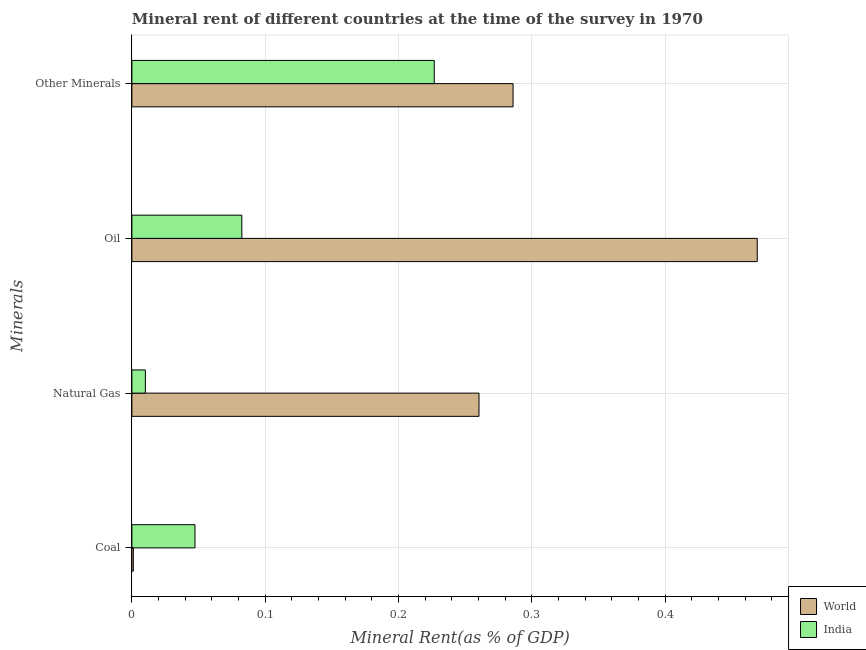How many different coloured bars are there?
Ensure brevity in your answer.  2. How many bars are there on the 4th tick from the top?
Offer a terse response. 2. How many bars are there on the 2nd tick from the bottom?
Ensure brevity in your answer.  2. What is the label of the 4th group of bars from the top?
Provide a succinct answer. Coal. What is the coal rent in India?
Ensure brevity in your answer.  0.05. Across all countries, what is the maximum oil rent?
Provide a succinct answer. 0.47. Across all countries, what is the minimum coal rent?
Your response must be concise. 0. In which country was the coal rent minimum?
Ensure brevity in your answer.  World. What is the total  rent of other minerals in the graph?
Keep it short and to the point. 0.51. What is the difference between the coal rent in World and that in India?
Your answer should be very brief. -0.05. What is the difference between the natural gas rent in World and the oil rent in India?
Give a very brief answer. 0.18. What is the average coal rent per country?
Provide a succinct answer. 0.02. What is the difference between the  rent of other minerals and oil rent in World?
Make the answer very short. -0.18. In how many countries, is the  rent of other minerals greater than 0.26 %?
Offer a terse response. 1. What is the ratio of the oil rent in India to that in World?
Ensure brevity in your answer.  0.18. Is the difference between the coal rent in India and World greater than the difference between the oil rent in India and World?
Give a very brief answer. Yes. What is the difference between the highest and the second highest natural gas rent?
Your answer should be very brief. 0.25. What is the difference between the highest and the lowest  rent of other minerals?
Provide a succinct answer. 0.06. Is the sum of the  rent of other minerals in World and India greater than the maximum oil rent across all countries?
Provide a succinct answer. Yes. Is it the case that in every country, the sum of the  rent of other minerals and natural gas rent is greater than the sum of oil rent and coal rent?
Keep it short and to the point. No. What does the 1st bar from the top in Natural Gas represents?
Offer a very short reply. India. What does the 1st bar from the bottom in Other Minerals represents?
Keep it short and to the point. World. Is it the case that in every country, the sum of the coal rent and natural gas rent is greater than the oil rent?
Ensure brevity in your answer.  No. How many countries are there in the graph?
Make the answer very short. 2. Are the values on the major ticks of X-axis written in scientific E-notation?
Provide a succinct answer. No. Does the graph contain any zero values?
Offer a terse response. No. Does the graph contain grids?
Your response must be concise. Yes. How many legend labels are there?
Make the answer very short. 2. What is the title of the graph?
Make the answer very short. Mineral rent of different countries at the time of the survey in 1970. Does "Kenya" appear as one of the legend labels in the graph?
Your answer should be compact. No. What is the label or title of the X-axis?
Offer a very short reply. Mineral Rent(as % of GDP). What is the label or title of the Y-axis?
Your answer should be compact. Minerals. What is the Mineral Rent(as % of GDP) in World in Coal?
Your response must be concise. 0. What is the Mineral Rent(as % of GDP) of India in Coal?
Offer a terse response. 0.05. What is the Mineral Rent(as % of GDP) in World in Natural Gas?
Offer a terse response. 0.26. What is the Mineral Rent(as % of GDP) in India in Natural Gas?
Offer a terse response. 0.01. What is the Mineral Rent(as % of GDP) of World in Oil?
Provide a succinct answer. 0.47. What is the Mineral Rent(as % of GDP) in India in Oil?
Offer a terse response. 0.08. What is the Mineral Rent(as % of GDP) of World in Other Minerals?
Offer a very short reply. 0.29. What is the Mineral Rent(as % of GDP) in India in Other Minerals?
Offer a terse response. 0.23. Across all Minerals, what is the maximum Mineral Rent(as % of GDP) in World?
Ensure brevity in your answer.  0.47. Across all Minerals, what is the maximum Mineral Rent(as % of GDP) of India?
Your response must be concise. 0.23. Across all Minerals, what is the minimum Mineral Rent(as % of GDP) of World?
Your answer should be very brief. 0. Across all Minerals, what is the minimum Mineral Rent(as % of GDP) of India?
Your answer should be very brief. 0.01. What is the total Mineral Rent(as % of GDP) of World in the graph?
Your response must be concise. 1.02. What is the total Mineral Rent(as % of GDP) of India in the graph?
Make the answer very short. 0.37. What is the difference between the Mineral Rent(as % of GDP) in World in Coal and that in Natural Gas?
Keep it short and to the point. -0.26. What is the difference between the Mineral Rent(as % of GDP) in India in Coal and that in Natural Gas?
Offer a very short reply. 0.04. What is the difference between the Mineral Rent(as % of GDP) in World in Coal and that in Oil?
Your answer should be compact. -0.47. What is the difference between the Mineral Rent(as % of GDP) of India in Coal and that in Oil?
Ensure brevity in your answer.  -0.04. What is the difference between the Mineral Rent(as % of GDP) in World in Coal and that in Other Minerals?
Give a very brief answer. -0.28. What is the difference between the Mineral Rent(as % of GDP) in India in Coal and that in Other Minerals?
Your answer should be very brief. -0.18. What is the difference between the Mineral Rent(as % of GDP) in World in Natural Gas and that in Oil?
Offer a very short reply. -0.21. What is the difference between the Mineral Rent(as % of GDP) in India in Natural Gas and that in Oil?
Your answer should be compact. -0.07. What is the difference between the Mineral Rent(as % of GDP) in World in Natural Gas and that in Other Minerals?
Provide a succinct answer. -0.03. What is the difference between the Mineral Rent(as % of GDP) of India in Natural Gas and that in Other Minerals?
Make the answer very short. -0.22. What is the difference between the Mineral Rent(as % of GDP) in World in Oil and that in Other Minerals?
Provide a short and direct response. 0.18. What is the difference between the Mineral Rent(as % of GDP) of India in Oil and that in Other Minerals?
Provide a short and direct response. -0.14. What is the difference between the Mineral Rent(as % of GDP) in World in Coal and the Mineral Rent(as % of GDP) in India in Natural Gas?
Provide a succinct answer. -0.01. What is the difference between the Mineral Rent(as % of GDP) in World in Coal and the Mineral Rent(as % of GDP) in India in Oil?
Make the answer very short. -0.08. What is the difference between the Mineral Rent(as % of GDP) in World in Coal and the Mineral Rent(as % of GDP) in India in Other Minerals?
Make the answer very short. -0.23. What is the difference between the Mineral Rent(as % of GDP) in World in Natural Gas and the Mineral Rent(as % of GDP) in India in Oil?
Give a very brief answer. 0.18. What is the difference between the Mineral Rent(as % of GDP) of World in Natural Gas and the Mineral Rent(as % of GDP) of India in Other Minerals?
Your answer should be very brief. 0.03. What is the difference between the Mineral Rent(as % of GDP) in World in Oil and the Mineral Rent(as % of GDP) in India in Other Minerals?
Keep it short and to the point. 0.24. What is the average Mineral Rent(as % of GDP) of World per Minerals?
Keep it short and to the point. 0.25. What is the average Mineral Rent(as % of GDP) in India per Minerals?
Keep it short and to the point. 0.09. What is the difference between the Mineral Rent(as % of GDP) in World and Mineral Rent(as % of GDP) in India in Coal?
Your response must be concise. -0.05. What is the difference between the Mineral Rent(as % of GDP) of World and Mineral Rent(as % of GDP) of India in Natural Gas?
Your response must be concise. 0.25. What is the difference between the Mineral Rent(as % of GDP) in World and Mineral Rent(as % of GDP) in India in Oil?
Your answer should be compact. 0.39. What is the difference between the Mineral Rent(as % of GDP) of World and Mineral Rent(as % of GDP) of India in Other Minerals?
Your answer should be very brief. 0.06. What is the ratio of the Mineral Rent(as % of GDP) in World in Coal to that in Natural Gas?
Ensure brevity in your answer.  0. What is the ratio of the Mineral Rent(as % of GDP) of India in Coal to that in Natural Gas?
Provide a short and direct response. 4.68. What is the ratio of the Mineral Rent(as % of GDP) of World in Coal to that in Oil?
Provide a short and direct response. 0. What is the ratio of the Mineral Rent(as % of GDP) in India in Coal to that in Oil?
Provide a short and direct response. 0.57. What is the ratio of the Mineral Rent(as % of GDP) in World in Coal to that in Other Minerals?
Make the answer very short. 0. What is the ratio of the Mineral Rent(as % of GDP) in India in Coal to that in Other Minerals?
Ensure brevity in your answer.  0.21. What is the ratio of the Mineral Rent(as % of GDP) in World in Natural Gas to that in Oil?
Provide a short and direct response. 0.56. What is the ratio of the Mineral Rent(as % of GDP) of India in Natural Gas to that in Oil?
Your answer should be compact. 0.12. What is the ratio of the Mineral Rent(as % of GDP) in World in Natural Gas to that in Other Minerals?
Ensure brevity in your answer.  0.91. What is the ratio of the Mineral Rent(as % of GDP) of India in Natural Gas to that in Other Minerals?
Your response must be concise. 0.04. What is the ratio of the Mineral Rent(as % of GDP) in World in Oil to that in Other Minerals?
Your answer should be very brief. 1.64. What is the ratio of the Mineral Rent(as % of GDP) in India in Oil to that in Other Minerals?
Ensure brevity in your answer.  0.36. What is the difference between the highest and the second highest Mineral Rent(as % of GDP) of World?
Ensure brevity in your answer.  0.18. What is the difference between the highest and the second highest Mineral Rent(as % of GDP) of India?
Keep it short and to the point. 0.14. What is the difference between the highest and the lowest Mineral Rent(as % of GDP) in World?
Provide a succinct answer. 0.47. What is the difference between the highest and the lowest Mineral Rent(as % of GDP) of India?
Make the answer very short. 0.22. 